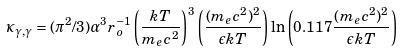Convert formula to latex. <formula><loc_0><loc_0><loc_500><loc_500>\kappa _ { \gamma , \gamma } = ( \pi ^ { 2 } / 3 ) \alpha ^ { 3 } r _ { o } ^ { - 1 } \left ( \frac { k T } { m _ { e } c ^ { 2 } } \right ) ^ { 3 } \left ( \frac { ( m _ { e } c ^ { 2 } ) ^ { 2 } } { \epsilon k T } \right ) \ln \left ( 0 . 1 1 7 \frac { ( m _ { e } c ^ { 2 } ) ^ { 2 } } { \epsilon k T } \right )</formula> 